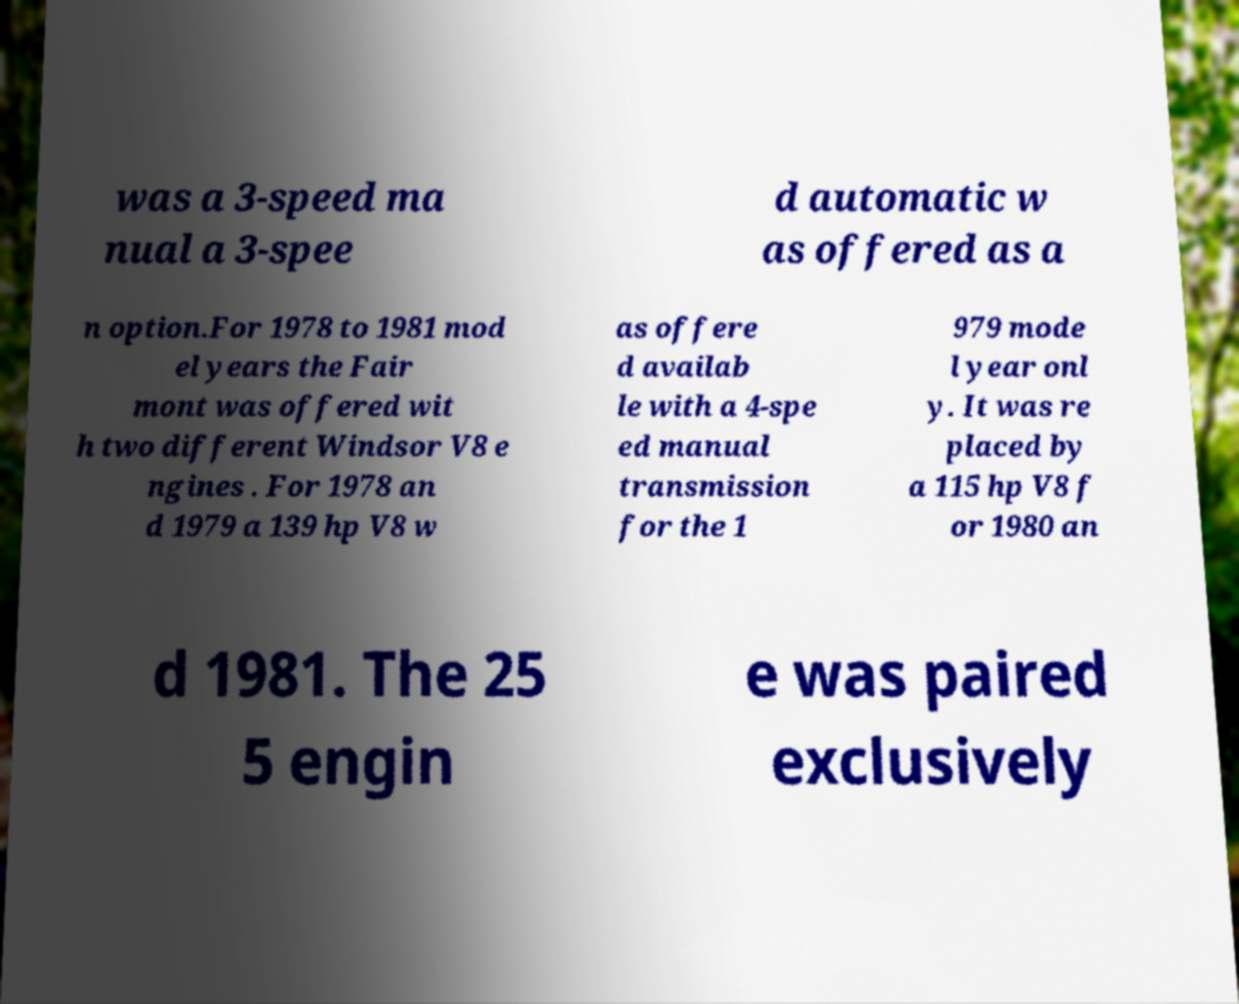I need the written content from this picture converted into text. Can you do that? was a 3-speed ma nual a 3-spee d automatic w as offered as a n option.For 1978 to 1981 mod el years the Fair mont was offered wit h two different Windsor V8 e ngines . For 1978 an d 1979 a 139 hp V8 w as offere d availab le with a 4-spe ed manual transmission for the 1 979 mode l year onl y. It was re placed by a 115 hp V8 f or 1980 an d 1981. The 25 5 engin e was paired exclusively 